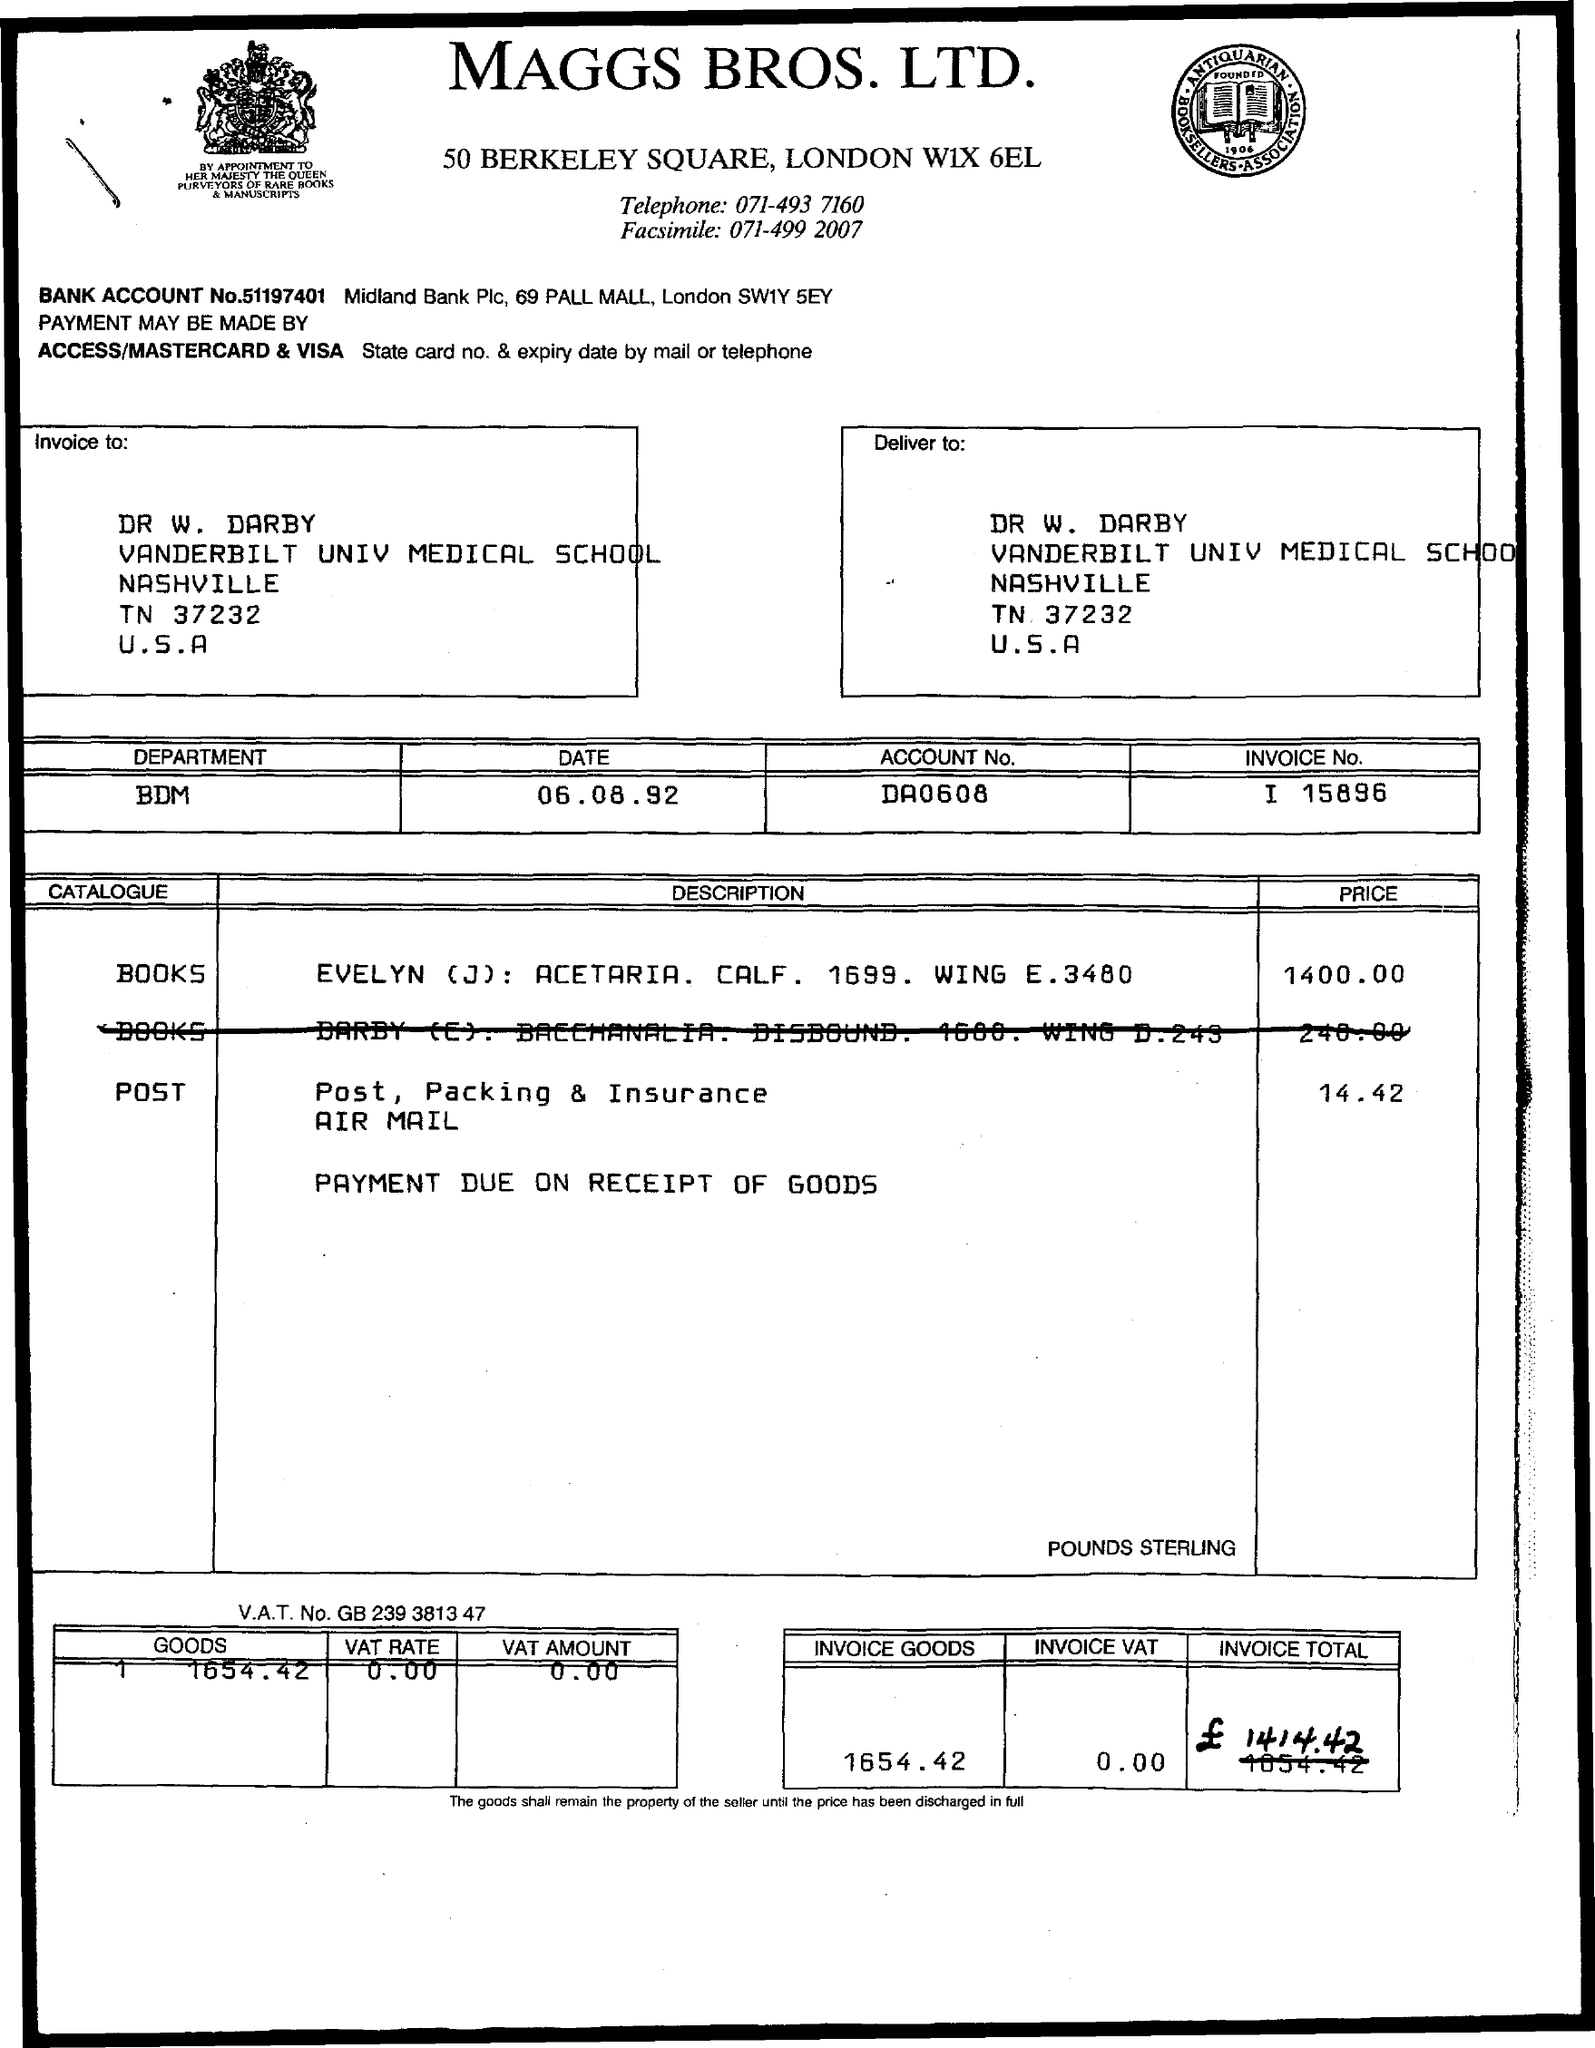What is the price of the post? The price of the post, packing, and insurance (air mail) as stated on the invoice is £14.42. 